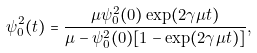<formula> <loc_0><loc_0><loc_500><loc_500>\psi _ { 0 } ^ { 2 } ( t ) = \frac { \mu \psi _ { 0 } ^ { 2 } ( 0 ) \exp ( 2 \gamma \mu t ) } { \mu - \psi _ { 0 } ^ { 2 } ( 0 ) [ 1 - \exp ( 2 \gamma \mu t ) ] } ,</formula> 